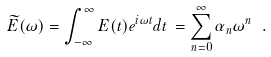<formula> <loc_0><loc_0><loc_500><loc_500>\widetilde { E } ( \omega ) = \int _ { - \infty } ^ { \infty } E ( t ) e ^ { i \omega t } d t \, = \sum _ { n = 0 } ^ { \infty } \alpha _ { n } \omega ^ { n } \ .</formula> 